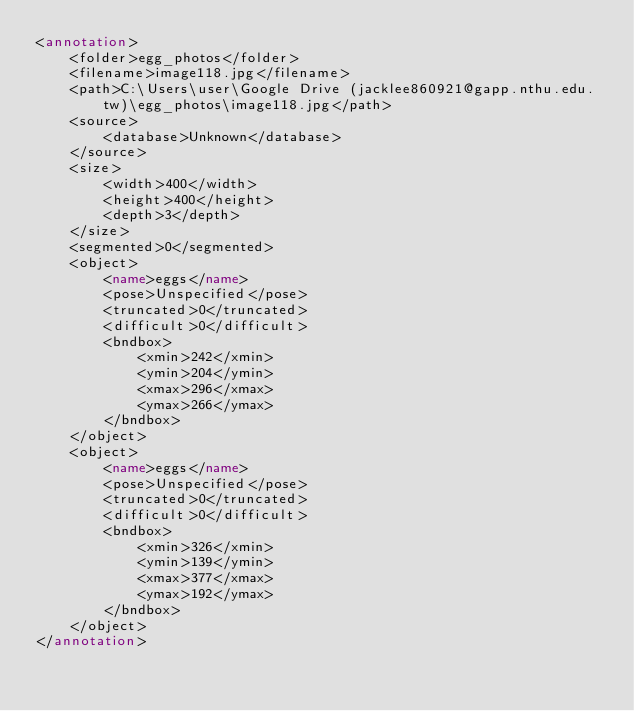Convert code to text. <code><loc_0><loc_0><loc_500><loc_500><_XML_><annotation>
	<folder>egg_photos</folder>
	<filename>image118.jpg</filename>
	<path>C:\Users\user\Google Drive (jacklee860921@gapp.nthu.edu.tw)\egg_photos\image118.jpg</path>
	<source>
		<database>Unknown</database>
	</source>
	<size>
		<width>400</width>
		<height>400</height>
		<depth>3</depth>
	</size>
	<segmented>0</segmented>
	<object>
		<name>eggs</name>
		<pose>Unspecified</pose>
		<truncated>0</truncated>
		<difficult>0</difficult>
		<bndbox>
			<xmin>242</xmin>
			<ymin>204</ymin>
			<xmax>296</xmax>
			<ymax>266</ymax>
		</bndbox>
	</object>
	<object>
		<name>eggs</name>
		<pose>Unspecified</pose>
		<truncated>0</truncated>
		<difficult>0</difficult>
		<bndbox>
			<xmin>326</xmin>
			<ymin>139</ymin>
			<xmax>377</xmax>
			<ymax>192</ymax>
		</bndbox>
	</object>
</annotation>
</code> 